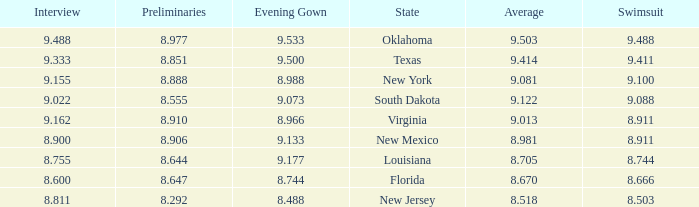What is the total number of average where evening gown is 8.988 1.0. 